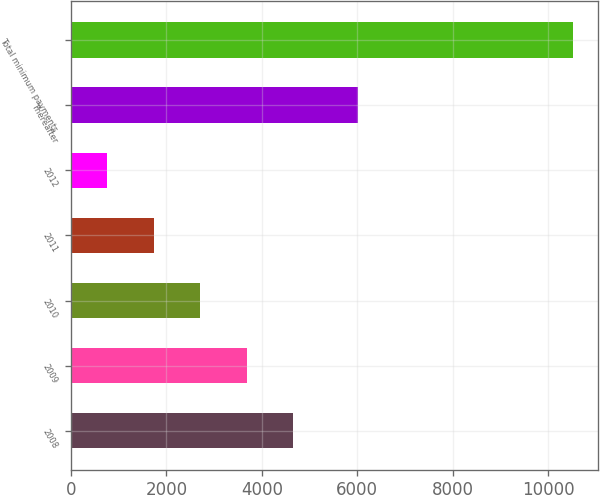Convert chart. <chart><loc_0><loc_0><loc_500><loc_500><bar_chart><fcel>2008<fcel>2009<fcel>2010<fcel>2011<fcel>2012<fcel>Thereafter<fcel>Total minimum payments<nl><fcel>4659.9<fcel>3684.25<fcel>2708.6<fcel>1732.95<fcel>757.3<fcel>6008.6<fcel>10513.8<nl></chart> 